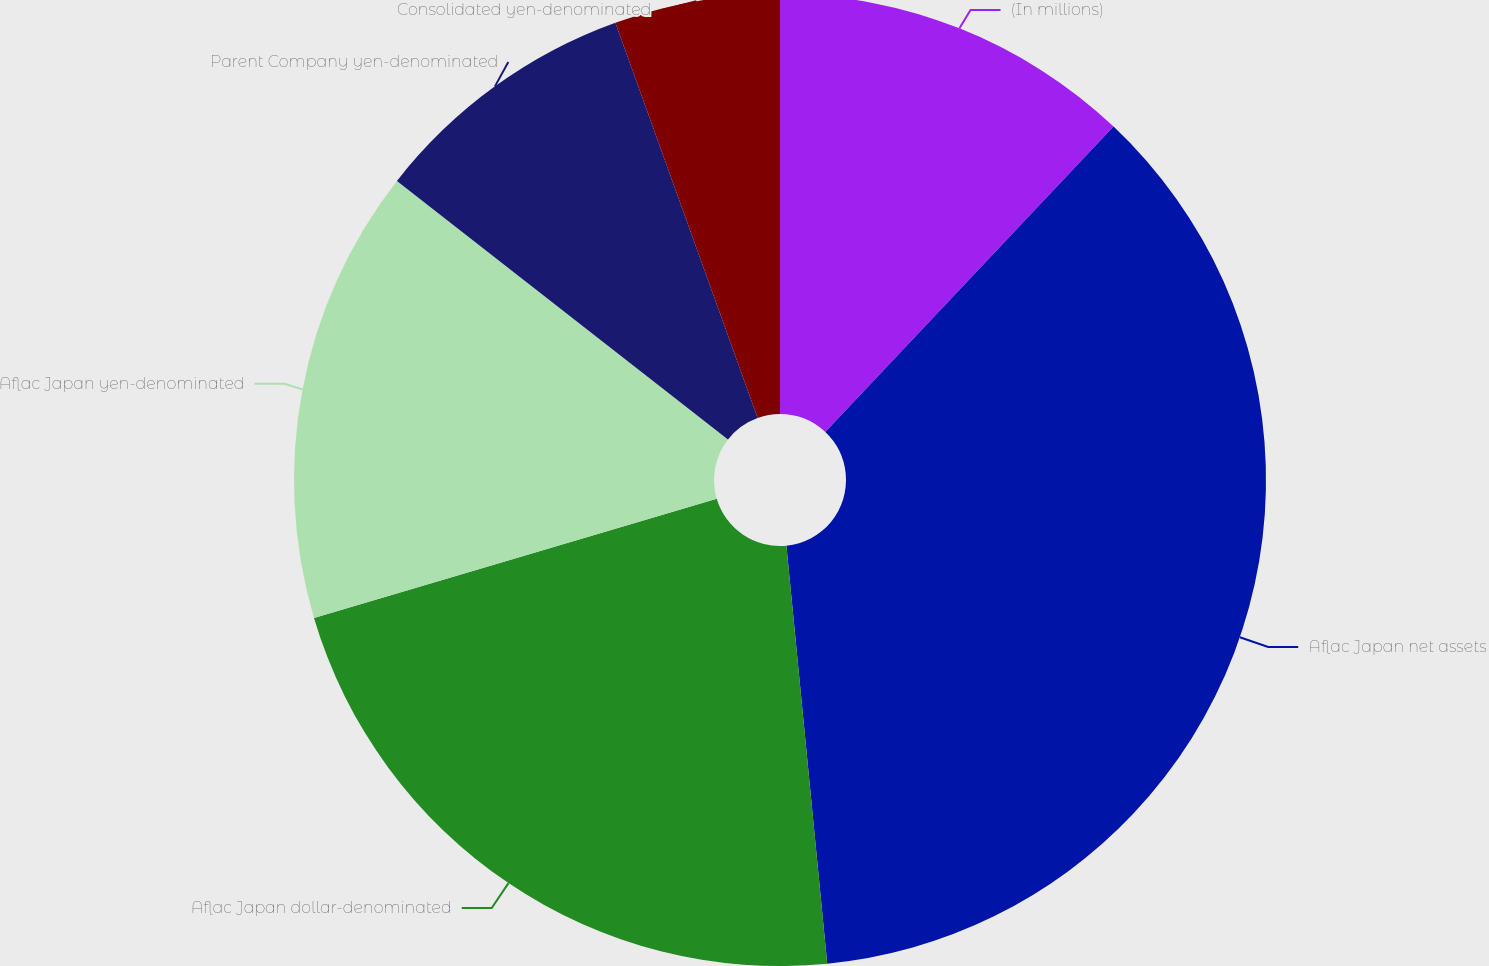Convert chart to OTSL. <chart><loc_0><loc_0><loc_500><loc_500><pie_chart><fcel>(In millions)<fcel>Aflac Japan net assets<fcel>Aflac Japan dollar-denominated<fcel>Aflac Japan yen-denominated<fcel>Parent Company yen-denominated<fcel>Consolidated yen-denominated<nl><fcel>12.04%<fcel>36.41%<fcel>21.97%<fcel>15.13%<fcel>8.95%<fcel>5.5%<nl></chart> 